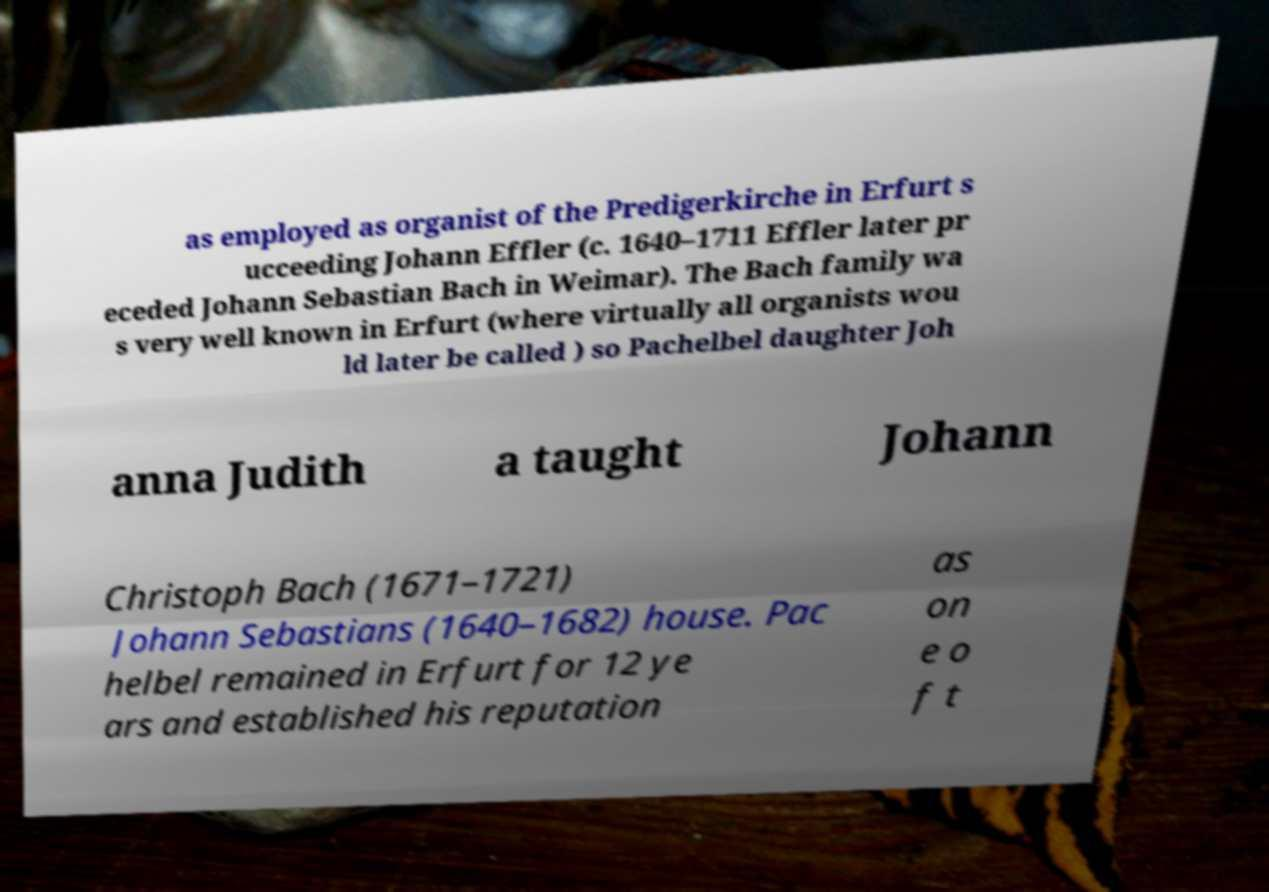There's text embedded in this image that I need extracted. Can you transcribe it verbatim? as employed as organist of the Predigerkirche in Erfurt s ucceeding Johann Effler (c. 1640–1711 Effler later pr eceded Johann Sebastian Bach in Weimar). The Bach family wa s very well known in Erfurt (where virtually all organists wou ld later be called ) so Pachelbel daughter Joh anna Judith a taught Johann Christoph Bach (1671–1721) Johann Sebastians (1640–1682) house. Pac helbel remained in Erfurt for 12 ye ars and established his reputation as on e o f t 